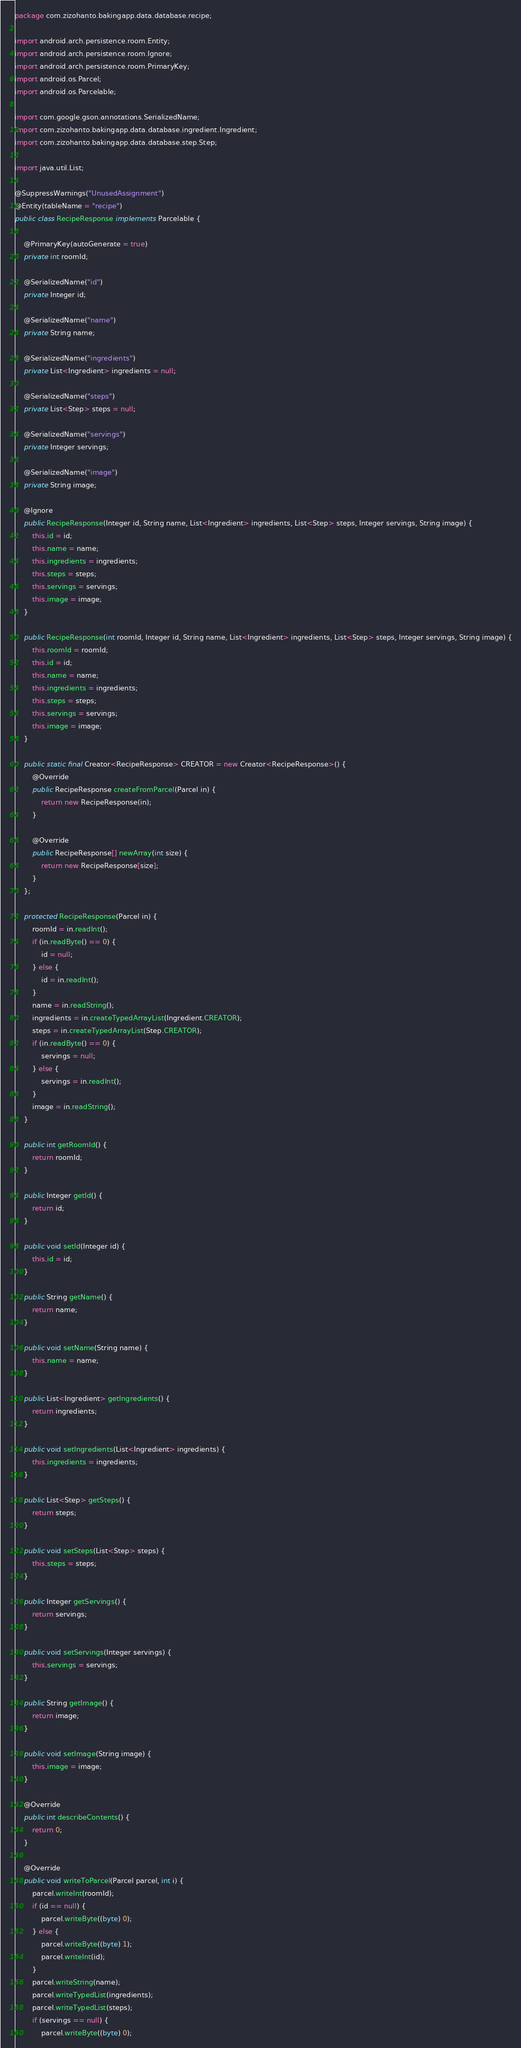Convert code to text. <code><loc_0><loc_0><loc_500><loc_500><_Java_>
package com.zizohanto.bakingapp.data.database.recipe;

import android.arch.persistence.room.Entity;
import android.arch.persistence.room.Ignore;
import android.arch.persistence.room.PrimaryKey;
import android.os.Parcel;
import android.os.Parcelable;

import com.google.gson.annotations.SerializedName;
import com.zizohanto.bakingapp.data.database.ingredient.Ingredient;
import com.zizohanto.bakingapp.data.database.step.Step;

import java.util.List;

@SuppressWarnings("UnusedAssignment")
@Entity(tableName = "recipe")
public class RecipeResponse implements Parcelable {

    @PrimaryKey(autoGenerate = true)
    private int roomId;

    @SerializedName("id")
    private Integer id;

    @SerializedName("name")
    private String name;

    @SerializedName("ingredients")
    private List<Ingredient> ingredients = null;

    @SerializedName("steps")
    private List<Step> steps = null;

    @SerializedName("servings")
    private Integer servings;

    @SerializedName("image")
    private String image;

    @Ignore
    public RecipeResponse(Integer id, String name, List<Ingredient> ingredients, List<Step> steps, Integer servings, String image) {
        this.id = id;
        this.name = name;
        this.ingredients = ingredients;
        this.steps = steps;
        this.servings = servings;
        this.image = image;
    }

    public RecipeResponse(int roomId, Integer id, String name, List<Ingredient> ingredients, List<Step> steps, Integer servings, String image) {
        this.roomId = roomId;
        this.id = id;
        this.name = name;
        this.ingredients = ingredients;
        this.steps = steps;
        this.servings = servings;
        this.image = image;
    }

    public static final Creator<RecipeResponse> CREATOR = new Creator<RecipeResponse>() {
        @Override
        public RecipeResponse createFromParcel(Parcel in) {
            return new RecipeResponse(in);
        }

        @Override
        public RecipeResponse[] newArray(int size) {
            return new RecipeResponse[size];
        }
    };

    protected RecipeResponse(Parcel in) {
        roomId = in.readInt();
        if (in.readByte() == 0) {
            id = null;
        } else {
            id = in.readInt();
        }
        name = in.readString();
        ingredients = in.createTypedArrayList(Ingredient.CREATOR);
        steps = in.createTypedArrayList(Step.CREATOR);
        if (in.readByte() == 0) {
            servings = null;
        } else {
            servings = in.readInt();
        }
        image = in.readString();
    }

    public int getRoomId() {
        return roomId;
    }

    public Integer getId() {
        return id;
    }

    public void setId(Integer id) {
        this.id = id;
    }

    public String getName() {
        return name;
    }

    public void setName(String name) {
        this.name = name;
    }

    public List<Ingredient> getIngredients() {
        return ingredients;
    }

    public void setIngredients(List<Ingredient> ingredients) {
        this.ingredients = ingredients;
    }

    public List<Step> getSteps() {
        return steps;
    }

    public void setSteps(List<Step> steps) {
        this.steps = steps;
    }

    public Integer getServings() {
        return servings;
    }

    public void setServings(Integer servings) {
        this.servings = servings;
    }

    public String getImage() {
        return image;
    }

    public void setImage(String image) {
        this.image = image;
    }

    @Override
    public int describeContents() {
        return 0;
    }

    @Override
    public void writeToParcel(Parcel parcel, int i) {
        parcel.writeInt(roomId);
        if (id == null) {
            parcel.writeByte((byte) 0);
        } else {
            parcel.writeByte((byte) 1);
            parcel.writeInt(id);
        }
        parcel.writeString(name);
        parcel.writeTypedList(ingredients);
        parcel.writeTypedList(steps);
        if (servings == null) {
            parcel.writeByte((byte) 0);</code> 